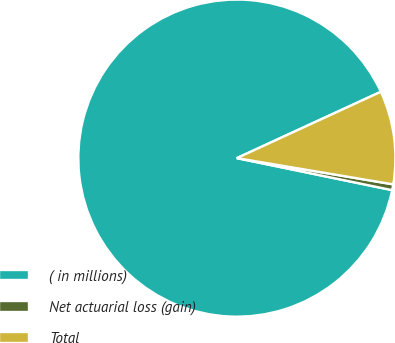<chart> <loc_0><loc_0><loc_500><loc_500><pie_chart><fcel>( in millions)<fcel>Net actuarial loss (gain)<fcel>Total<nl><fcel>89.89%<fcel>0.59%<fcel>9.52%<nl></chart> 